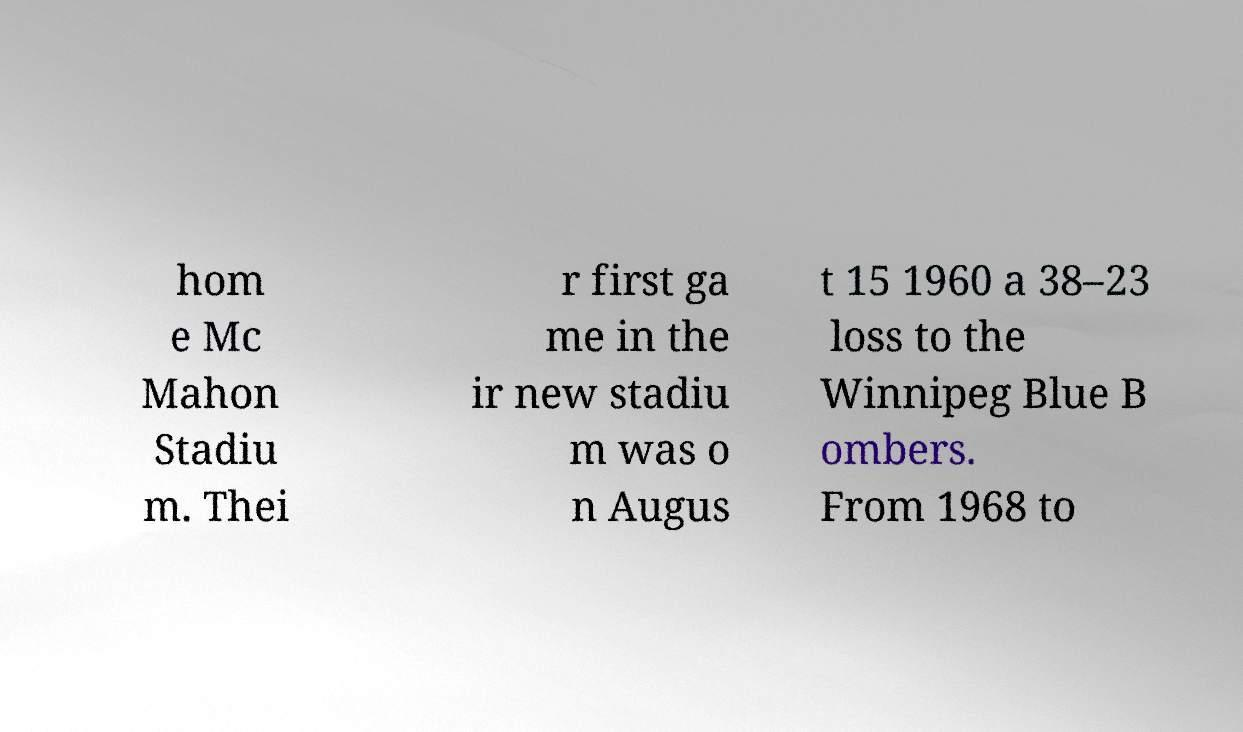Can you accurately transcribe the text from the provided image for me? hom e Mc Mahon Stadiu m. Thei r first ga me in the ir new stadiu m was o n Augus t 15 1960 a 38–23 loss to the Winnipeg Blue B ombers. From 1968 to 